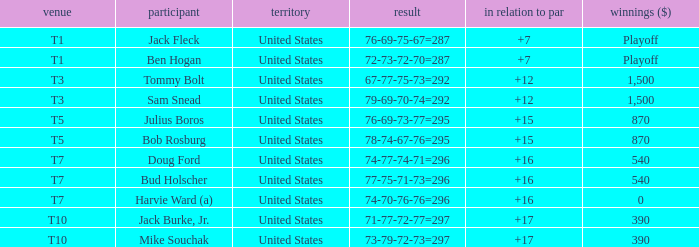What is average to par when Bud Holscher is the player? 16.0. 